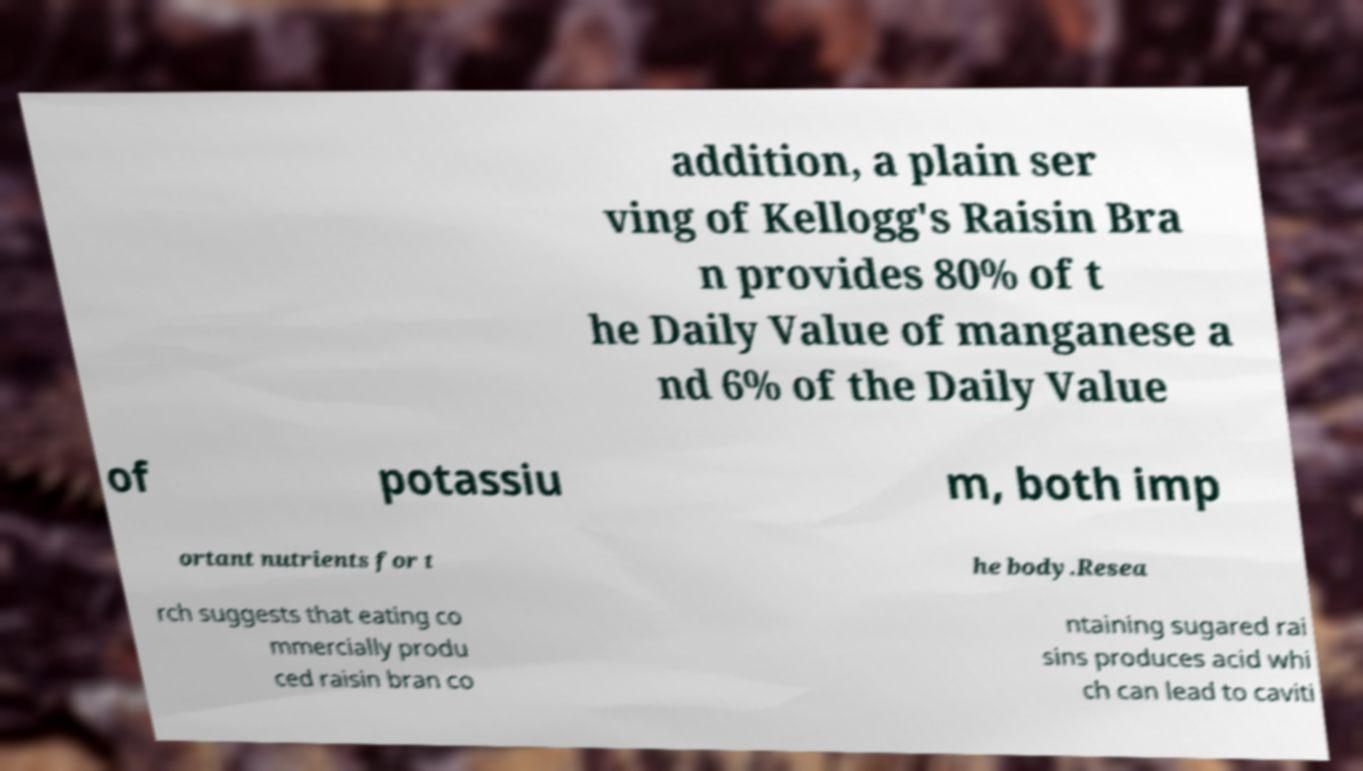There's text embedded in this image that I need extracted. Can you transcribe it verbatim? addition, a plain ser ving of Kellogg's Raisin Bra n provides 80% of t he Daily Value of manganese a nd 6% of the Daily Value of potassiu m, both imp ortant nutrients for t he body.Resea rch suggests that eating co mmercially produ ced raisin bran co ntaining sugared rai sins produces acid whi ch can lead to caviti 